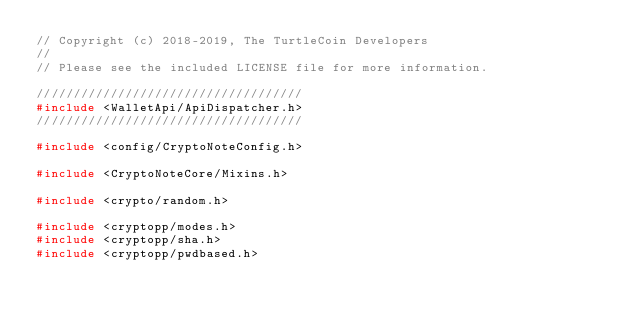<code> <loc_0><loc_0><loc_500><loc_500><_C++_>// Copyright (c) 2018-2019, The TurtleCoin Developers
// 
// Please see the included LICENSE file for more information.

////////////////////////////////////
#include <WalletApi/ApiDispatcher.h>
////////////////////////////////////

#include <config/CryptoNoteConfig.h>

#include <CryptoNoteCore/Mixins.h>

#include <crypto/random.h>

#include <cryptopp/modes.h>
#include <cryptopp/sha.h>
#include <cryptopp/pwdbased.h>
</code> 